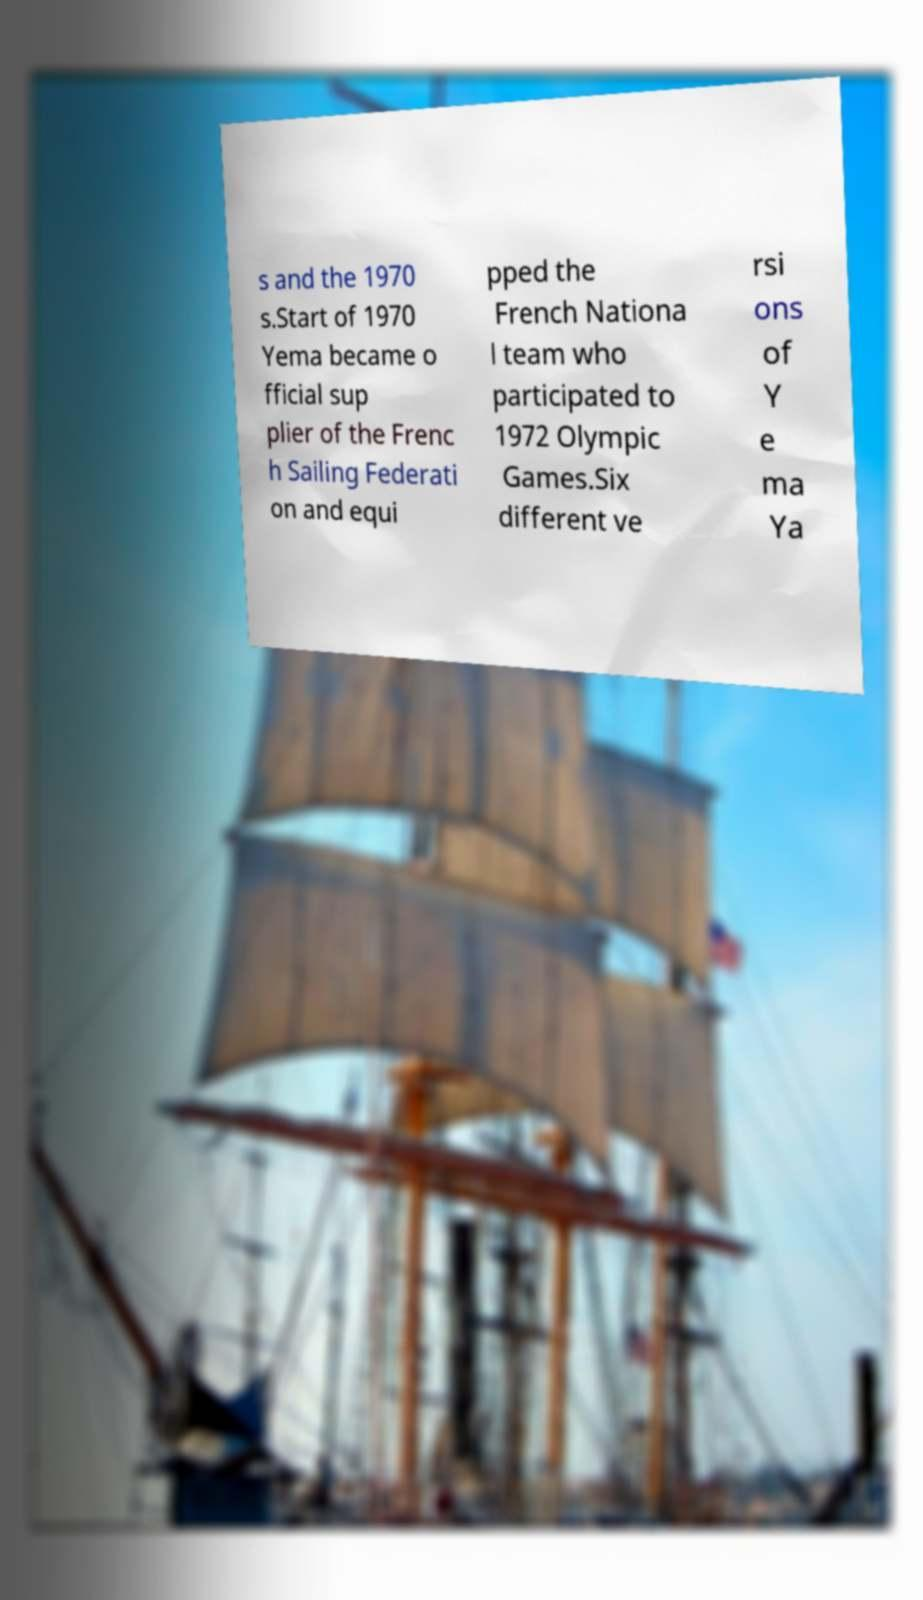Could you assist in decoding the text presented in this image and type it out clearly? s and the 1970 s.Start of 1970 Yema became o fficial sup plier of the Frenc h Sailing Federati on and equi pped the French Nationa l team who participated to 1972 Olympic Games.Six different ve rsi ons of Y e ma Ya 